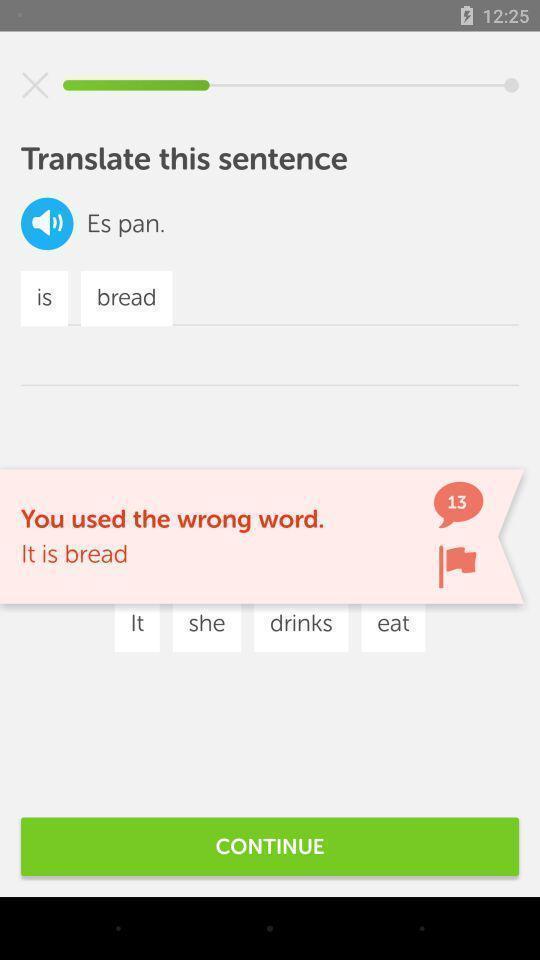Please provide a description for this image. Page of an translator application. 